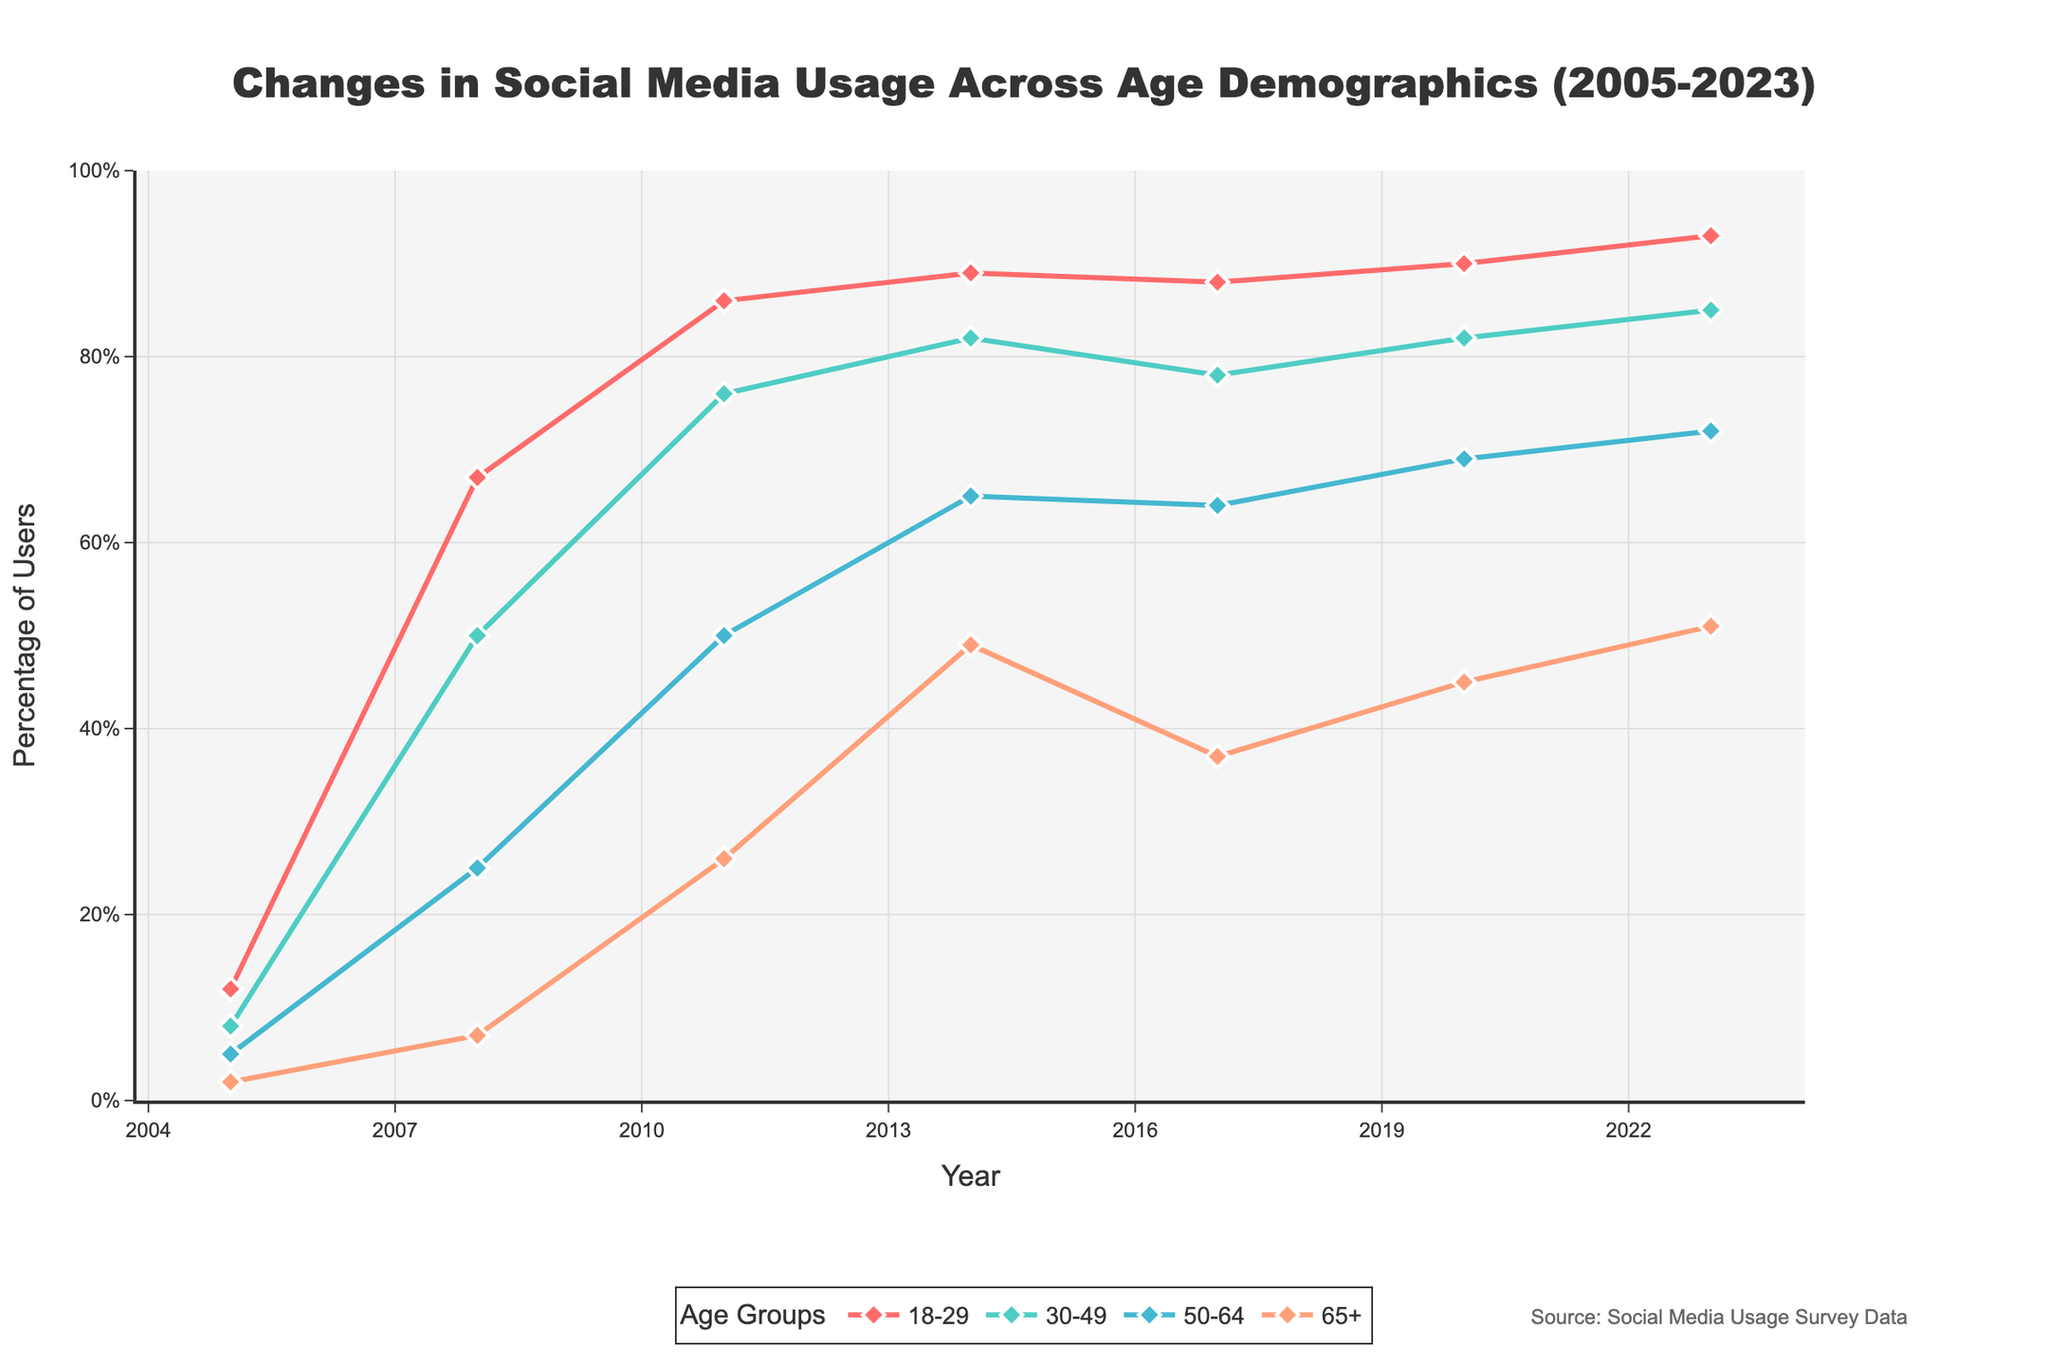What age group had the highest increase in social media usage between 2005 and 2023? Look at the starting point in 2005 and the endpoint in 2023 for each age group. Subtract the 2005 value from the 2023 value for each group: 18-29 (93-12=81), 30-49 (85-8=77), 50-64 (72-5=67), 65+ (51-2=49). The 18-29 group had the highest increase.
Answer: 18-29 Which age group had the lowest social media usage percentage in 2011? Look at the values for all age groups in 2011: 18-29 (86%), 30-49 (76%), 50-64 (50%), 65+ (26%). The 65+ group had the lowest percentage.
Answer: 65+ In which year did the social media usage for the 50-64 age group reach 50%? Locate the year when the 50-64 usage first hits or exceeds 50%. In the data, this happens in 2011 with 50%.
Answer: 2011 How does the social media usage in 2020 for the 30-49 age group compare to that in 2017? Check values for the 30-49 age group in 2017 (78%) and 2020 (82%). Subtract 2017 from 2020: 82 - 78 = 4. The usage increased by 4 percentage points.
Answer: Increased by 4% What was the average social media usage among all age groups in 2008? Add the usage percentages for all age groups in 2008 and divide by the number of groups: (67+50+25+7)/4 = 149/4 = 37.25%.
Answer: 37.25% Which age group shows the smallest increase from 2017 to 2023? Calculate the difference between 2023 and 2017 for each age group: 18-29 (93-88=5), 30-49 (85-78=7), 50-64 (72-64=8), 65+ (51-37=14). The 18-29 group shows the smallest increase.
Answer: 18-29 What is the trend of social media usage for the 65+ age group from 2005 to 2023? Examine the 65+ group values over the years: 2005 (2%), 2008 (7%), 2011 (26%), 2014 (49%), 2017 (37%), 2020 (45%), 2023 (51%). Despite fluctuations, the general trend is an upward increase.
Answer: Increasing trend Between which consecutive years did the 30-49 age group see the largest jump in social media usage? Compare the year-to-year differences for the 30-49 group: 2005-2008 (50-8=42), 2008-2011 (76-50=26), 2011-2014 (82-76=6), 2014-2017 (78-82=-4), 2017-2020 (82-78=4), 2020-2023 (85-82=3). The largest jump is between 2005 and 2008.
Answer: 2005-2008 By how many percentage points did the usage in the 50-64 age group increase from 2005 to 2020? Subtract 2005 percentage from 2020 for the 50-64 age group: 69 - 5 = 64.
Answer: 64 percentage points 